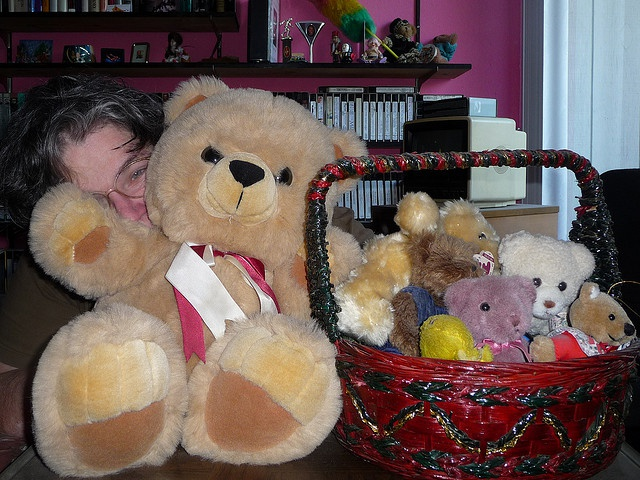Describe the objects in this image and their specific colors. I can see teddy bear in black, tan, gray, and darkgray tones, people in black, gray, and salmon tones, teddy bear in black, tan, darkgray, and gray tones, tv in black, darkgray, and lightblue tones, and teddy bear in black, gray, and maroon tones in this image. 